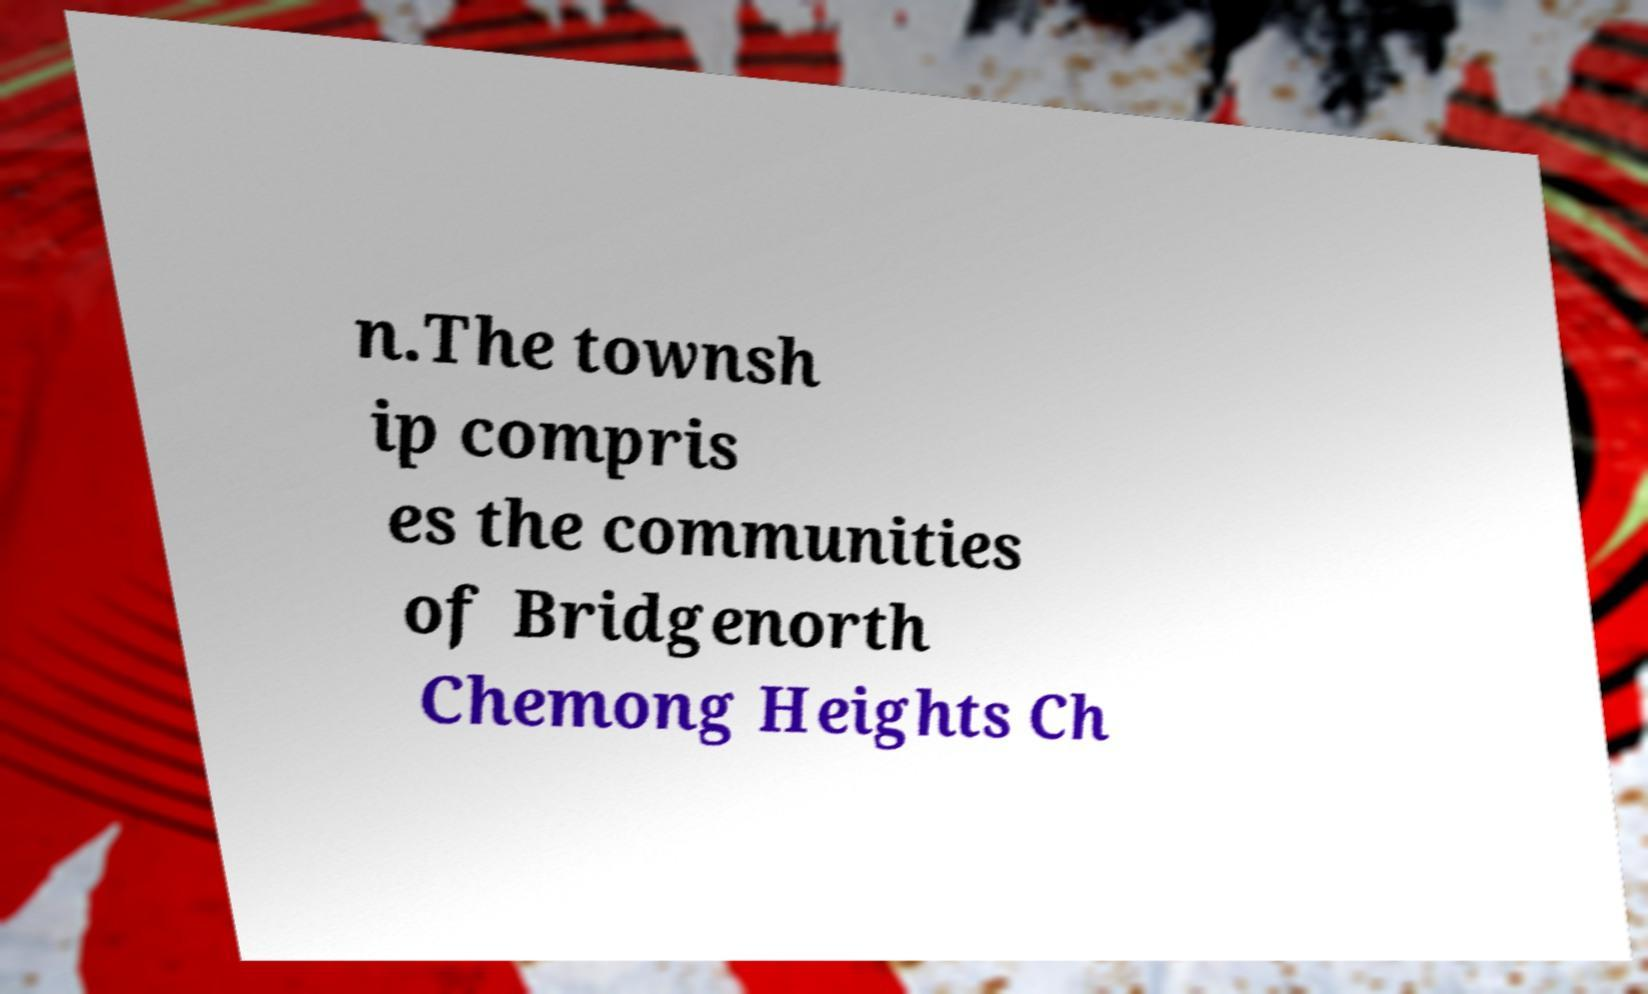Could you extract and type out the text from this image? n.The townsh ip compris es the communities of Bridgenorth Chemong Heights Ch 